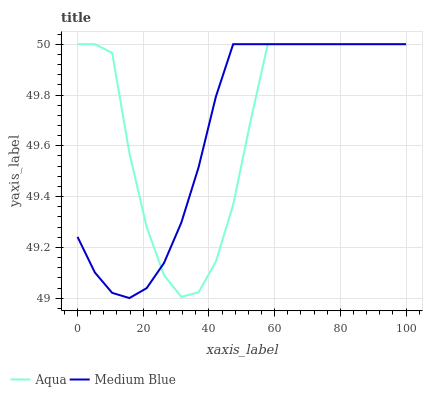Does Aqua have the minimum area under the curve?
Answer yes or no. No. Is Aqua the smoothest?
Answer yes or no. No. Does Aqua have the lowest value?
Answer yes or no. No. 